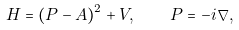<formula> <loc_0><loc_0><loc_500><loc_500>H = ( P - A ) ^ { 2 } + V , \quad P = - i \nabla ,</formula> 